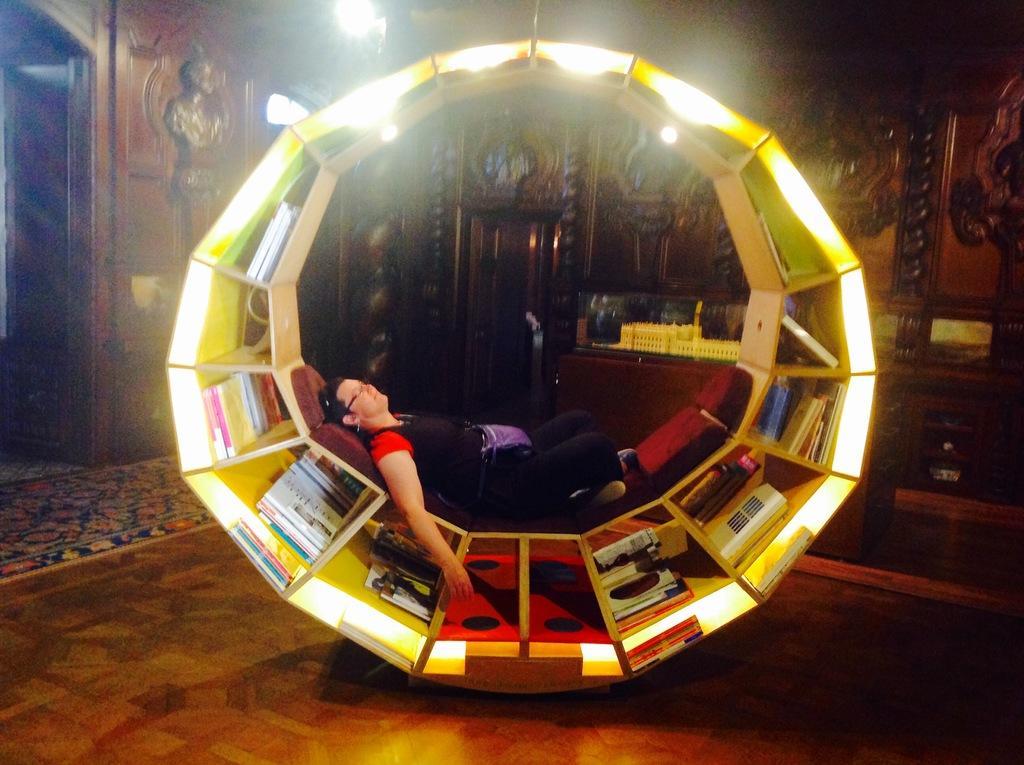Please provide a concise description of this image. This image is taken indoors. At the bottom of the image there is a floor. In the background there is a wall with carvings and sculptures and there is a light. In the middle of the image there is a book shelf with many books, which is in a wheel shape and a man is lying on the couch and there is a table with a few things on it. 